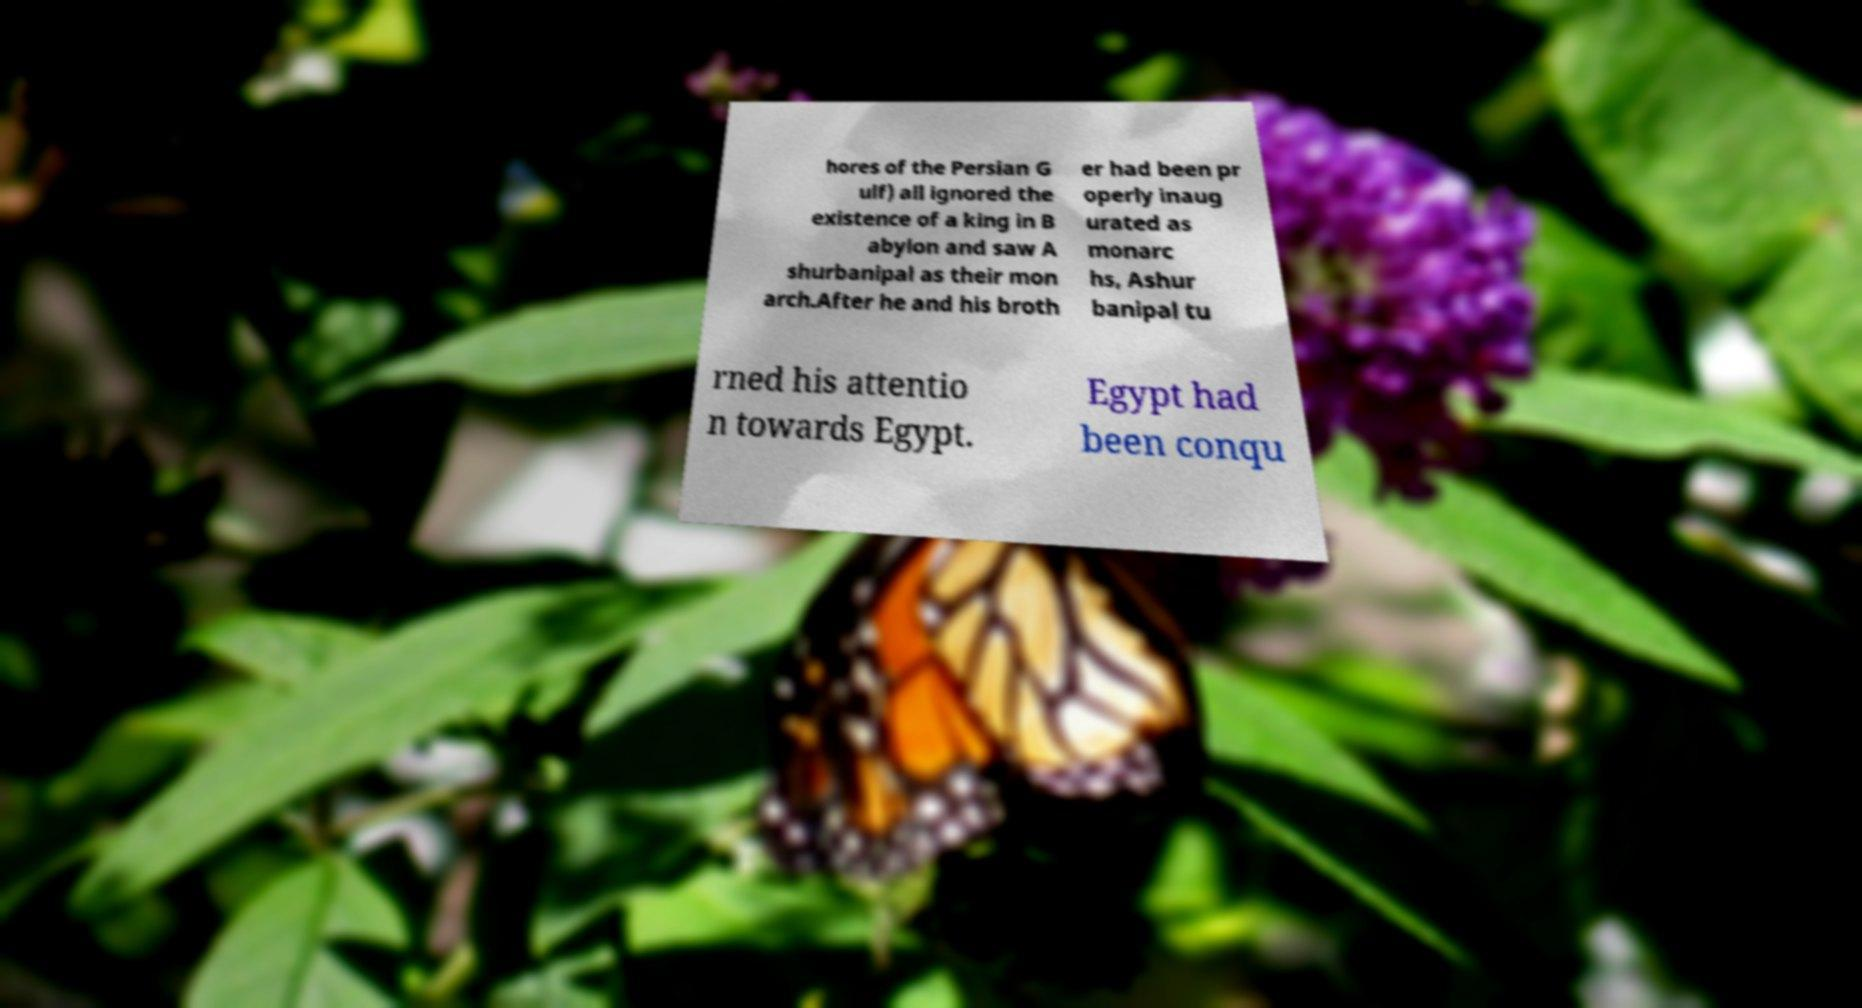Could you extract and type out the text from this image? hores of the Persian G ulf) all ignored the existence of a king in B abylon and saw A shurbanipal as their mon arch.After he and his broth er had been pr operly inaug urated as monarc hs, Ashur banipal tu rned his attentio n towards Egypt. Egypt had been conqu 